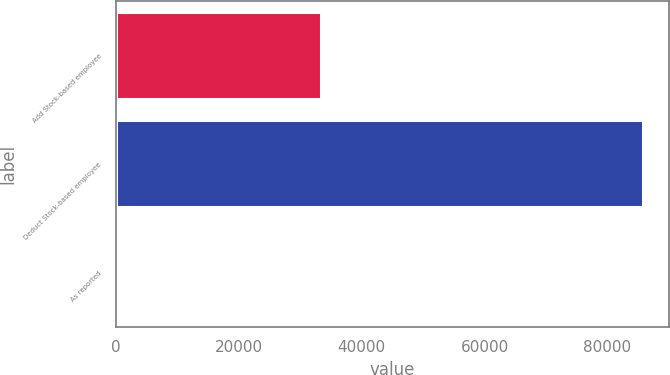<chart> <loc_0><loc_0><loc_500><loc_500><bar_chart><fcel>Add Stock-based employee<fcel>Deduct Stock-based employee<fcel>As reported<nl><fcel>33321<fcel>85719<fcel>0.18<nl></chart> 